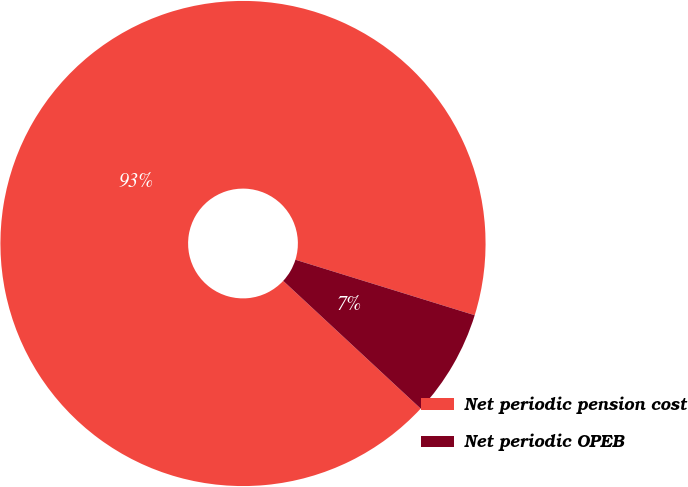<chart> <loc_0><loc_0><loc_500><loc_500><pie_chart><fcel>Net periodic pension cost<fcel>Net periodic OPEB<nl><fcel>92.86%<fcel>7.14%<nl></chart> 